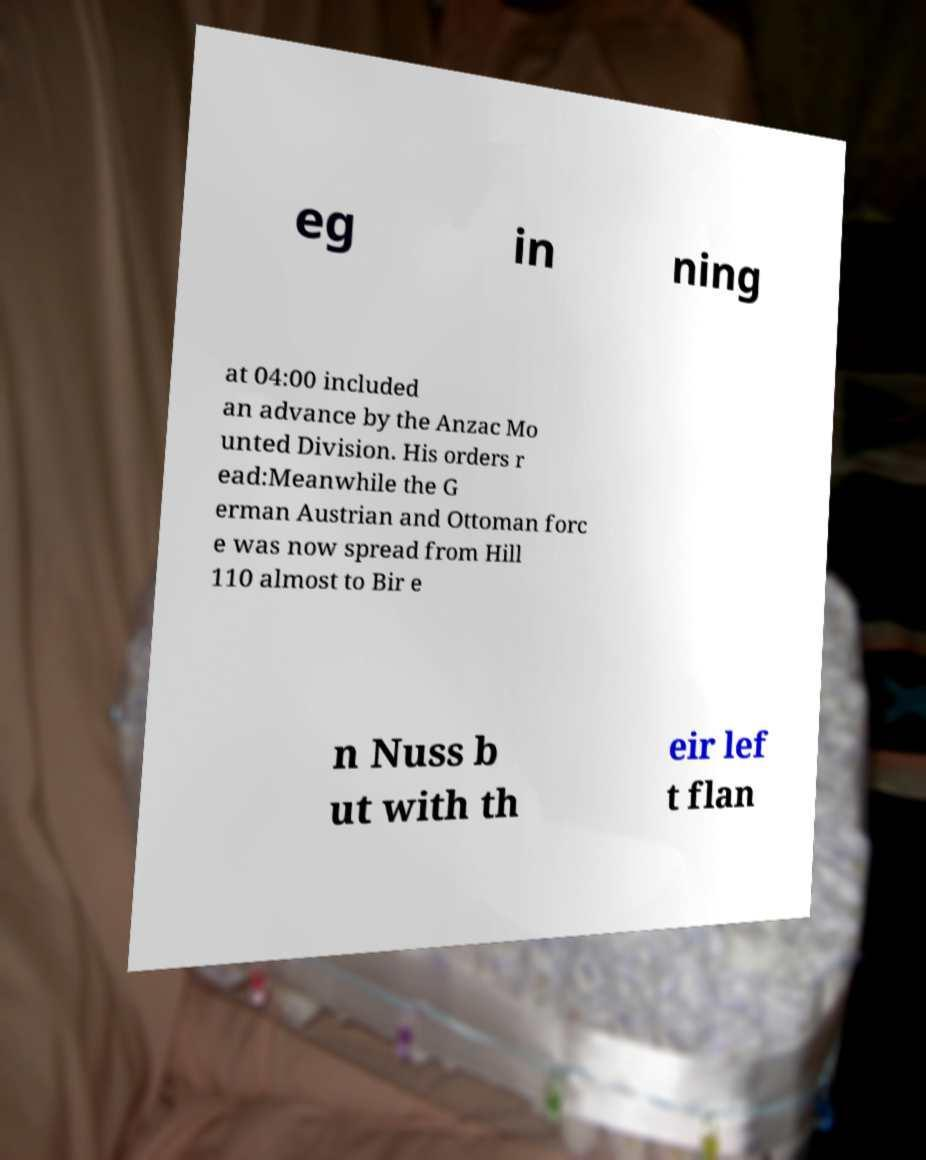I need the written content from this picture converted into text. Can you do that? eg in ning at 04:00 included an advance by the Anzac Mo unted Division. His orders r ead:Meanwhile the G erman Austrian and Ottoman forc e was now spread from Hill 110 almost to Bir e n Nuss b ut with th eir lef t flan 